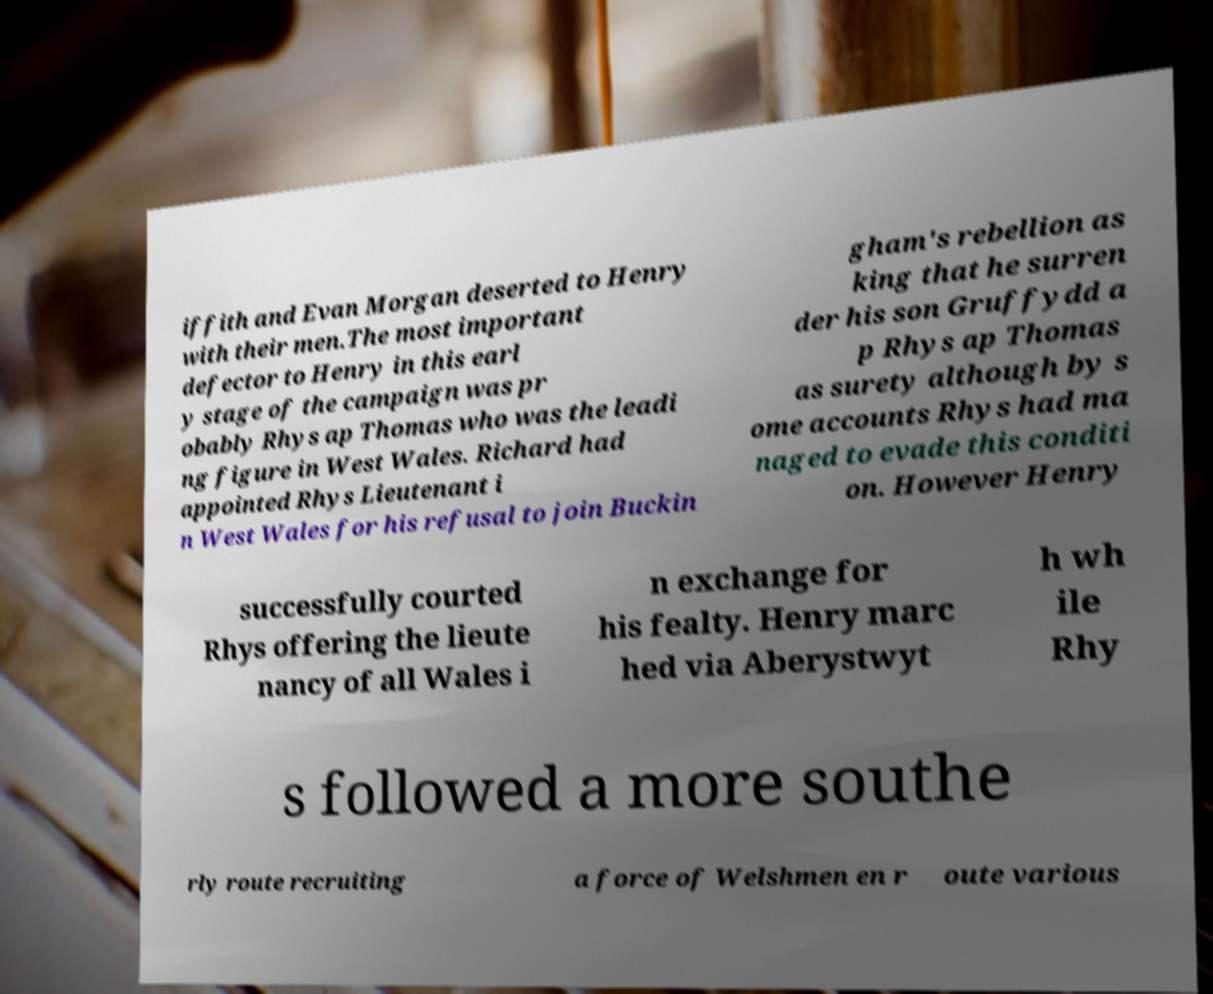Could you assist in decoding the text presented in this image and type it out clearly? iffith and Evan Morgan deserted to Henry with their men.The most important defector to Henry in this earl y stage of the campaign was pr obably Rhys ap Thomas who was the leadi ng figure in West Wales. Richard had appointed Rhys Lieutenant i n West Wales for his refusal to join Buckin gham's rebellion as king that he surren der his son Gruffydd a p Rhys ap Thomas as surety although by s ome accounts Rhys had ma naged to evade this conditi on. However Henry successfully courted Rhys offering the lieute nancy of all Wales i n exchange for his fealty. Henry marc hed via Aberystwyt h wh ile Rhy s followed a more southe rly route recruiting a force of Welshmen en r oute various 